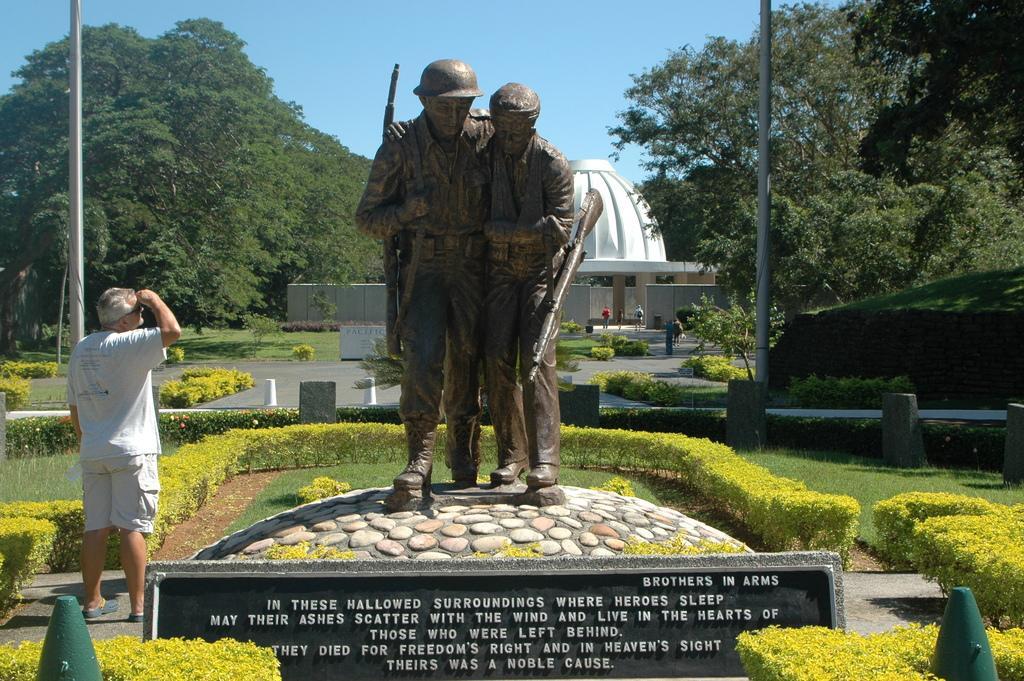Please provide a concise description of this image. In the center of the image we can see the brothers statue. We can also see the text on the concrete structure. There is a man standing on the left. Image also consists of plants, small pillars, grass, road and also poles. In the background, we can see the trees, monument and also the wall and some people. Sky is also visible. 